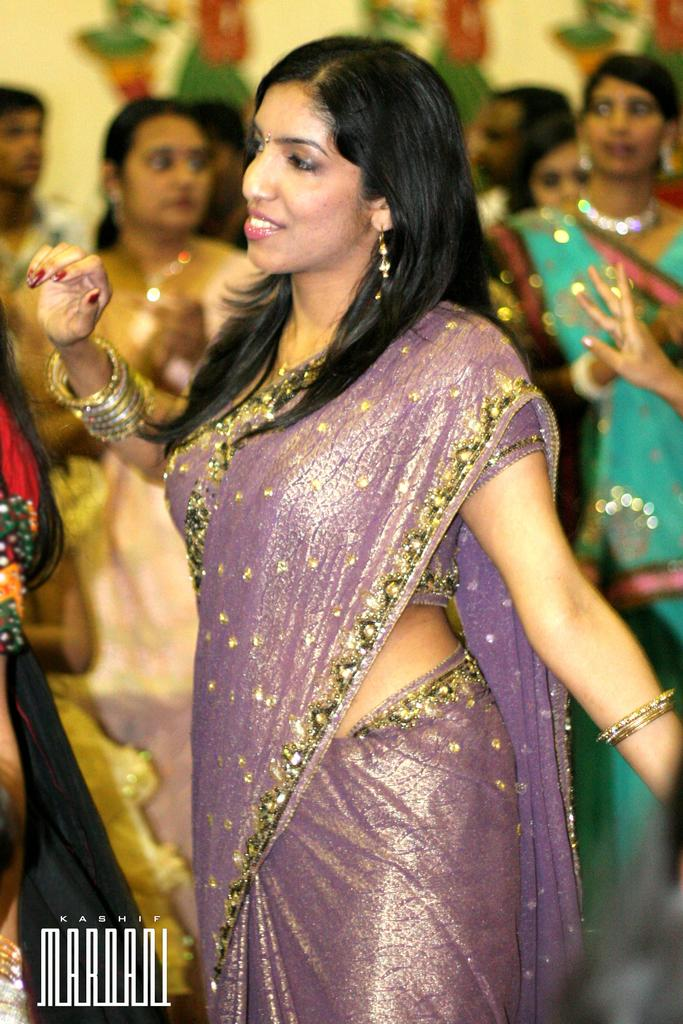Who is the main subject in the image? There is a woman in the image. What is the woman wearing? The woman is wearing a saree. Where is the woman located in the image? The woman is standing in the middle of the image. What else can be seen in the image besides the woman? There are other buildings visible in the image. What type of discussion is taking place between the woman and her grandfather in the image? There is no discussion or grandfather present in the image; it only features a woman standing in the middle of the image. How many bikes are visible in the image? There are no bikes visible in the image; it only features a woman and other buildings. 